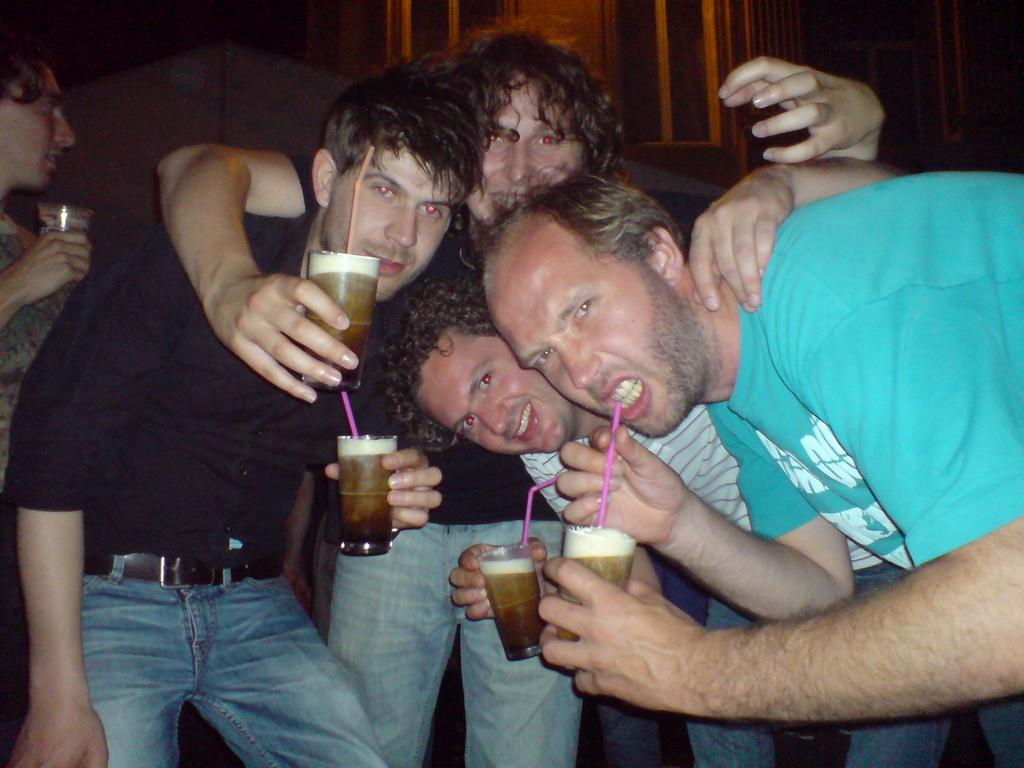What is the main subject of the image? The main subject of the image is men standing. Where are the men standing in the image? The men are standing on the floor. What are the men holding in their hands? The men are holding beverage glasses in their hands. What type of wine can be seen in the glasses held by the men in the image? There is no wine visible in the image; the men are holding beverage glasses, but the contents are not specified. 